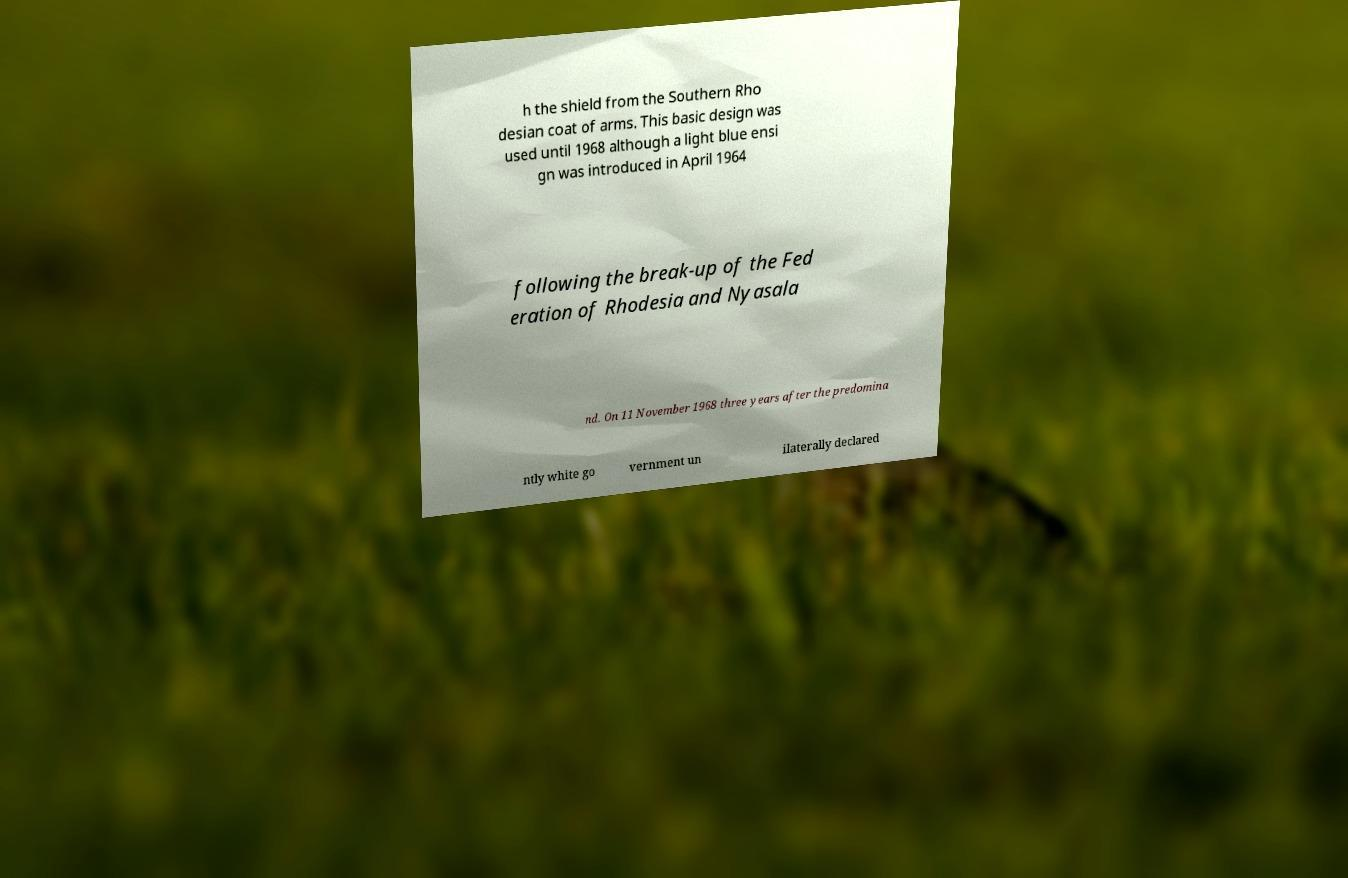Could you extract and type out the text from this image? h the shield from the Southern Rho desian coat of arms. This basic design was used until 1968 although a light blue ensi gn was introduced in April 1964 following the break-up of the Fed eration of Rhodesia and Nyasala nd. On 11 November 1968 three years after the predomina ntly white go vernment un ilaterally declared 